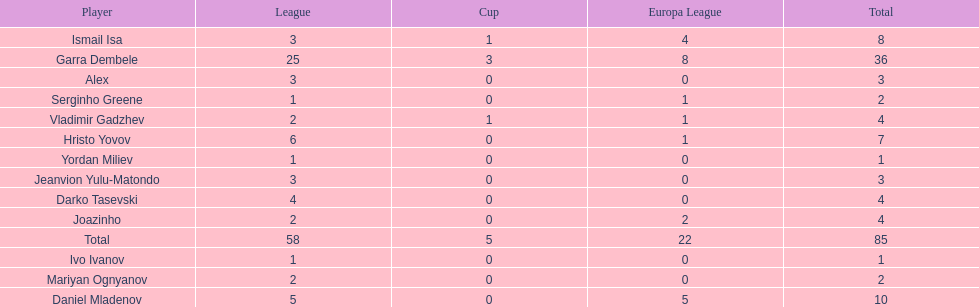How many of the players did not score any goals in the cup? 10. 